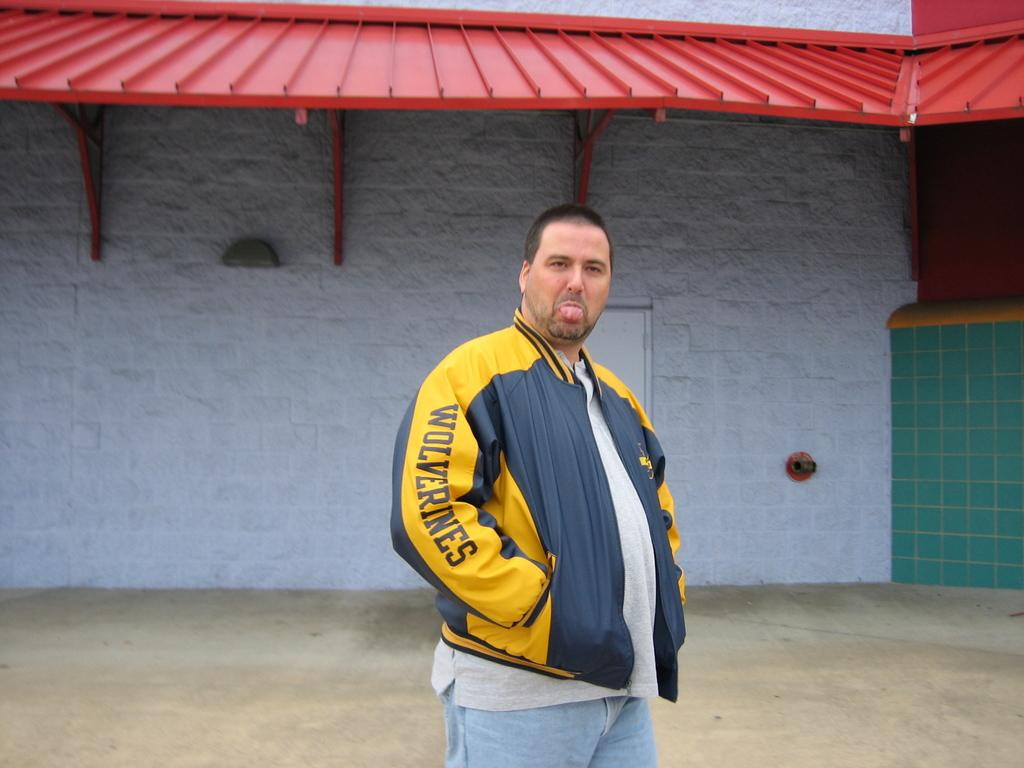<image>
Describe the image concisely. the name wolverines is on the sleeve of a man 